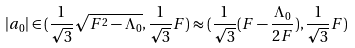Convert formula to latex. <formula><loc_0><loc_0><loc_500><loc_500>| a _ { 0 } | \in ( \frac { 1 } { \sqrt { 3 } } \sqrt { F ^ { 2 } - \Lambda _ { 0 } } , \frac { 1 } { \sqrt { 3 } } F ) \approx ( \frac { 1 } { \sqrt { 3 } } ( F - \frac { \Lambda _ { 0 } } { 2 F } ) , \frac { 1 } { \sqrt { 3 } } F )</formula> 